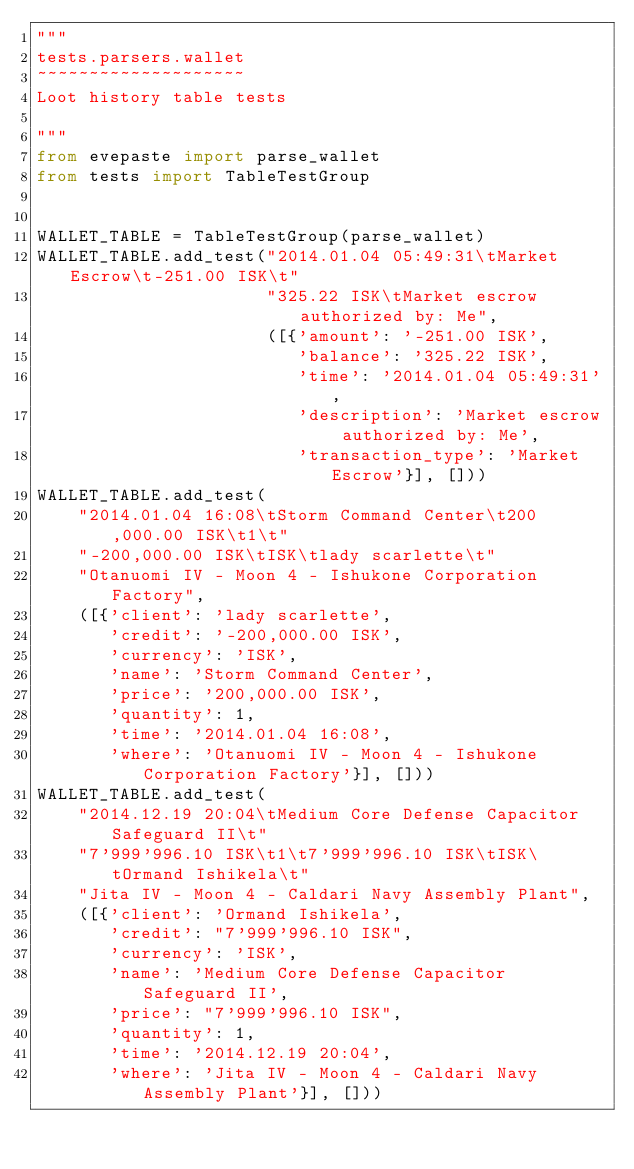<code> <loc_0><loc_0><loc_500><loc_500><_Python_>"""
tests.parsers.wallet
~~~~~~~~~~~~~~~~~~~~
Loot history table tests

"""
from evepaste import parse_wallet
from tests import TableTestGroup


WALLET_TABLE = TableTestGroup(parse_wallet)
WALLET_TABLE.add_test("2014.01.04 05:49:31\tMarket Escrow\t-251.00 ISK\t"
                      "325.22 ISK\tMarket escrow authorized by: Me",
                      ([{'amount': '-251.00 ISK',
                         'balance': '325.22 ISK',
                         'time': '2014.01.04 05:49:31',
                         'description': 'Market escrow authorized by: Me',
                         'transaction_type': 'Market Escrow'}], []))
WALLET_TABLE.add_test(
    "2014.01.04 16:08\tStorm Command Center\t200,000.00 ISK\t1\t"
    "-200,000.00 ISK\tISK\tlady scarlette\t"
    "Otanuomi IV - Moon 4 - Ishukone Corporation Factory",
    ([{'client': 'lady scarlette',
       'credit': '-200,000.00 ISK',
       'currency': 'ISK',
       'name': 'Storm Command Center',
       'price': '200,000.00 ISK',
       'quantity': 1,
       'time': '2014.01.04 16:08',
       'where': 'Otanuomi IV - Moon 4 - Ishukone Corporation Factory'}], []))
WALLET_TABLE.add_test(
    "2014.12.19 20:04\tMedium Core Defense Capacitor Safeguard II\t"
    "7'999'996.10 ISK\t1\t7'999'996.10 ISK\tISK\tOrmand Ishikela\t"
    "Jita IV - Moon 4 - Caldari Navy Assembly Plant",
    ([{'client': 'Ormand Ishikela',
       'credit': "7'999'996.10 ISK",
       'currency': 'ISK',
       'name': 'Medium Core Defense Capacitor Safeguard II',
       'price': "7'999'996.10 ISK",
       'quantity': 1,
       'time': '2014.12.19 20:04',
       'where': 'Jita IV - Moon 4 - Caldari Navy Assembly Plant'}], []))
</code> 